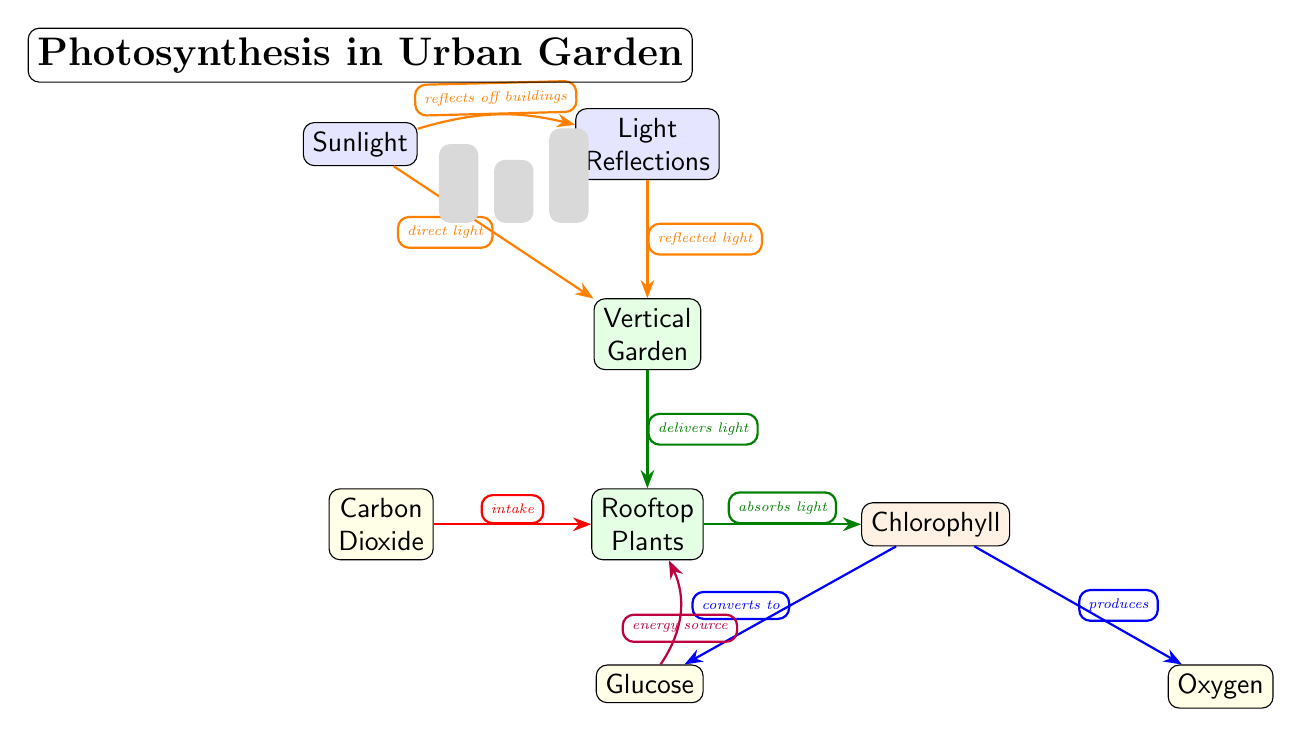What is the role of chlorophyll in the diagram? Chlorophyll is the process node that indicates the conversion of light absorbed by rooftop plants into glucose and oxygen. Both outputs directly follow from the chlorophyll node, and it signifies the energy transformation that occurs during photosynthesis.
Answer: Converts to glucose and produces oxygen How many urban design features are illustrated in the diagram? The diagram depicts two urban design features: light reflections off buildings (reflection) and the incorporation of a vertical garden (vertical). Both elements contribute to the photosynthesis process in the urban garden.
Answer: Two What type of light does the vertical garden receive from the sunlight? The vertical garden receives direct light from sunlight as indicated by the direct arrow connecting the sunlight node to the vertical node, demonstrating that sunlight directly influences the vertical gardening element.
Answer: Direct light What do rooftop plants absorb during the photosynthesis process? Rooftop plants absorb sunlight and carbon dioxide, both of which are vital for the process of photosynthesis. The diagram highlights the intake arrow from carbon dioxide to rooftop plants, indicating this critical aspect.
Answer: Sunlight and carbon dioxide Which product of chlorophyll is an energy source for rooftop plants? The product that serves as an energy source for the rooftop plants is glucose, as illustrated by the arrow labeled "energy source" flowing from the glucose node to the rooftop plants node, indicating its pivotal role in energy supply.
Answer: Glucose How are light reflections described in the diagram? Light reflections are described as reflecting off buildings, which is explicitly mentioned in the flow of the diagram from the sunlight node to the reflection node before reaching the vertical garden.
Answer: Reflects off buildings What color represents the process occurring in chlorophyll? The process occurring in chlorophyll is represented by the color blue in the diagram, indicating its significance as a transformative process in the photosynthesis cycle—converting absorbed light into glucose and oxygen.
Answer: Blue Which element is required for the rooftop plants' photosynthesis? The element required for rooftop plants' photosynthesis is carbon dioxide, as shown by the intake arrow leading towards the rooftop plants node, signifying its necessity in the photosynthetic process.
Answer: Carbon dioxide 